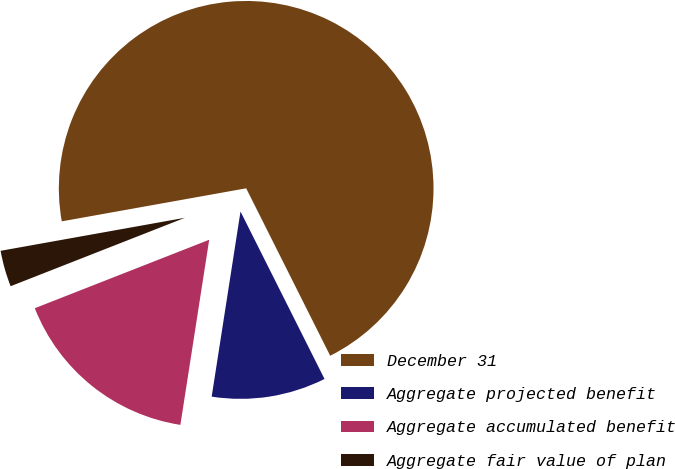<chart> <loc_0><loc_0><loc_500><loc_500><pie_chart><fcel>December 31<fcel>Aggregate projected benefit<fcel>Aggregate accumulated benefit<fcel>Aggregate fair value of plan<nl><fcel>70.42%<fcel>9.86%<fcel>16.59%<fcel>3.13%<nl></chart> 